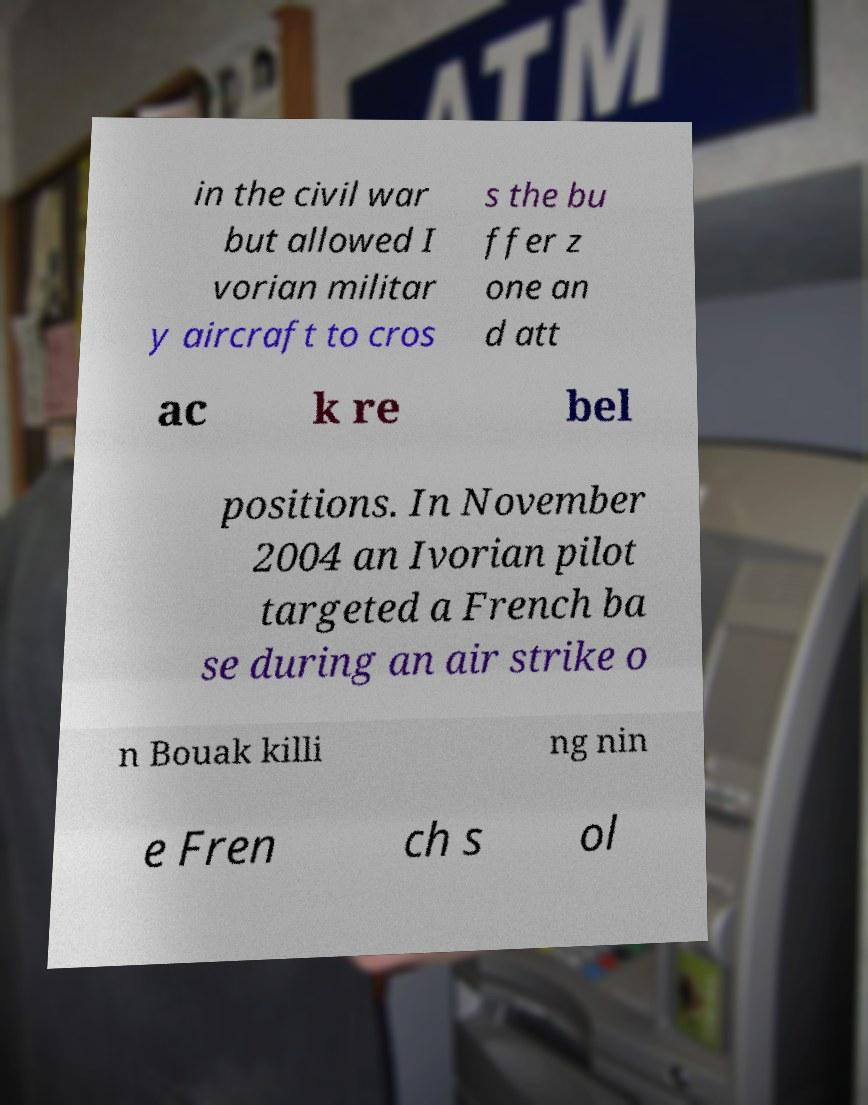Could you assist in decoding the text presented in this image and type it out clearly? in the civil war but allowed I vorian militar y aircraft to cros s the bu ffer z one an d att ac k re bel positions. In November 2004 an Ivorian pilot targeted a French ba se during an air strike o n Bouak killi ng nin e Fren ch s ol 